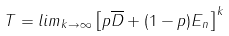<formula> <loc_0><loc_0><loc_500><loc_500>T = l i m _ { k \to \infty } \left [ p \overline { D } + ( 1 - p ) E _ { n } \right ] ^ { k }</formula> 